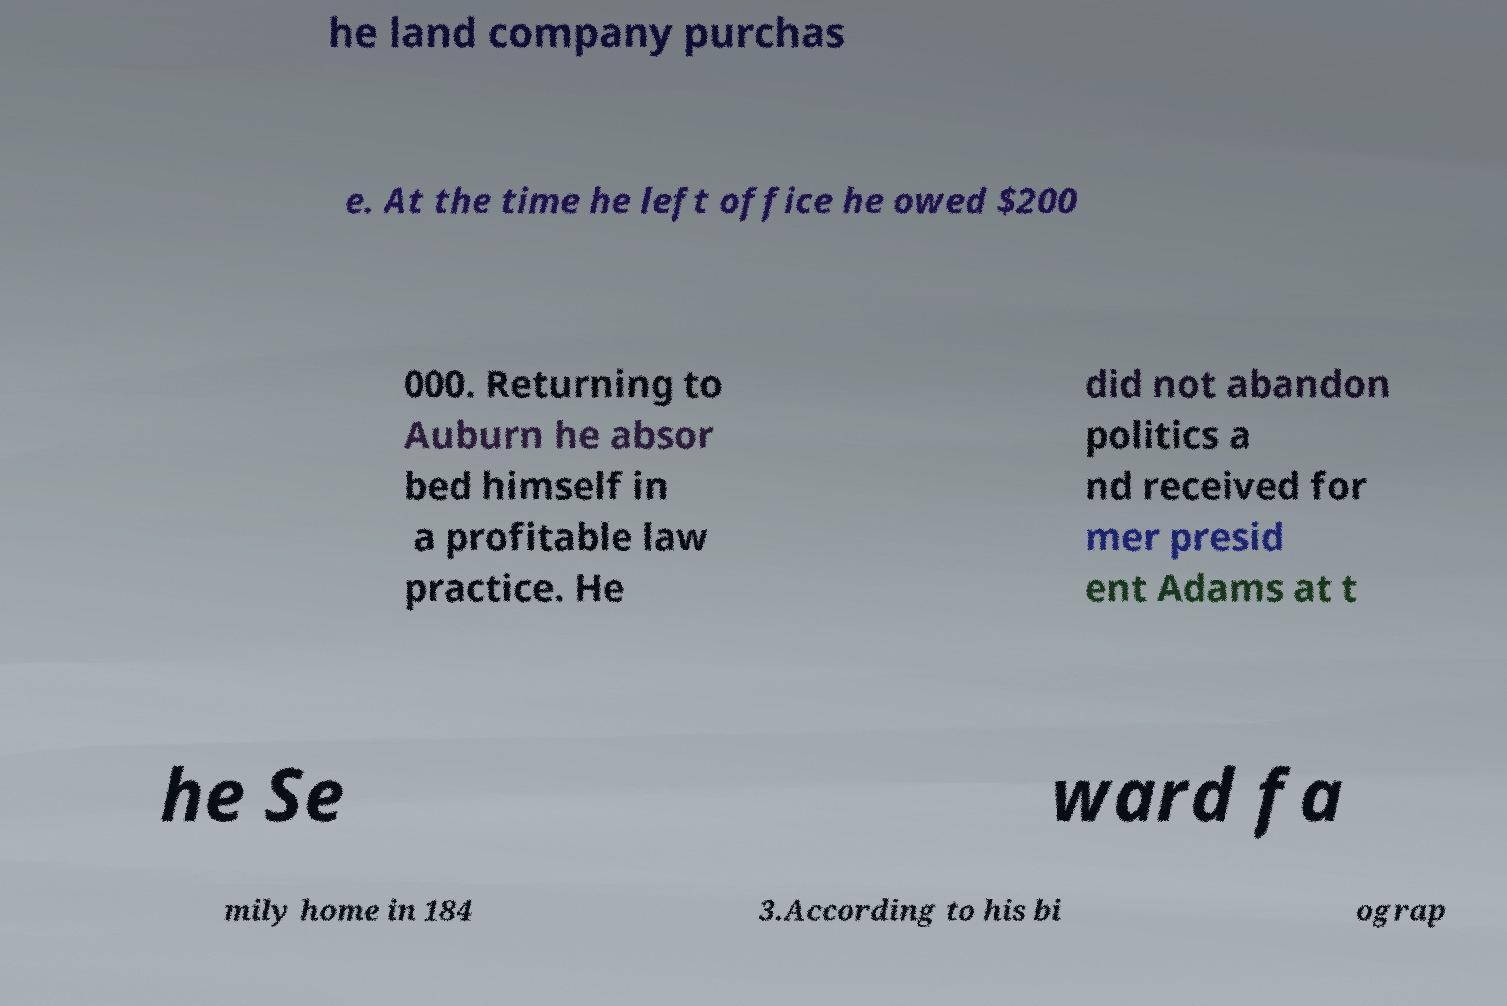Can you read and provide the text displayed in the image?This photo seems to have some interesting text. Can you extract and type it out for me? he land company purchas e. At the time he left office he owed $200 000. Returning to Auburn he absor bed himself in a profitable law practice. He did not abandon politics a nd received for mer presid ent Adams at t he Se ward fa mily home in 184 3.According to his bi ograp 